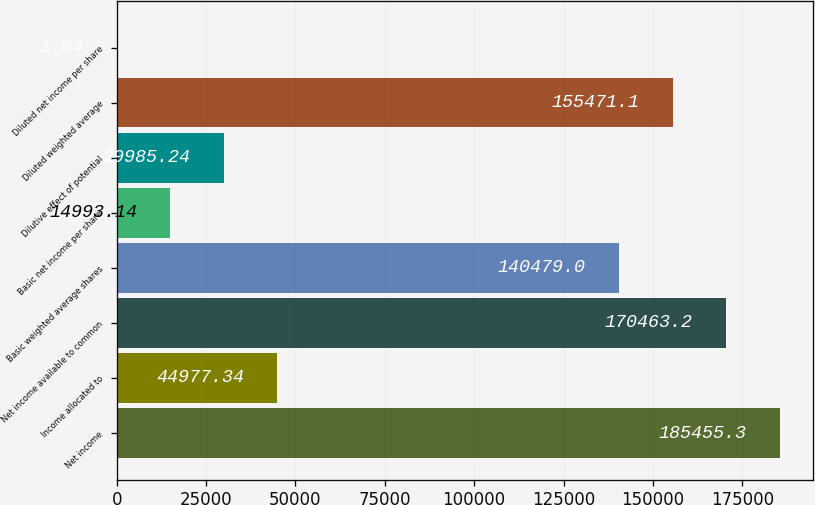Convert chart. <chart><loc_0><loc_0><loc_500><loc_500><bar_chart><fcel>Net income<fcel>Income allocated to<fcel>Net income available to common<fcel>Basic weighted average shares<fcel>Basic net income per share<fcel>Dilutive effect of potential<fcel>Diluted weighted average<fcel>Diluted net income per share<nl><fcel>185455<fcel>44977.3<fcel>170463<fcel>140479<fcel>14993.1<fcel>29985.2<fcel>155471<fcel>1.04<nl></chart> 